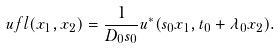<formula> <loc_0><loc_0><loc_500><loc_500>\ u f l ( x _ { 1 } , x _ { 2 } ) = \frac { 1 } { D _ { 0 } s _ { 0 } } u ^ { * } ( s _ { 0 } x _ { 1 } , t _ { 0 } + \lambda _ { 0 } x _ { 2 } ) .</formula> 